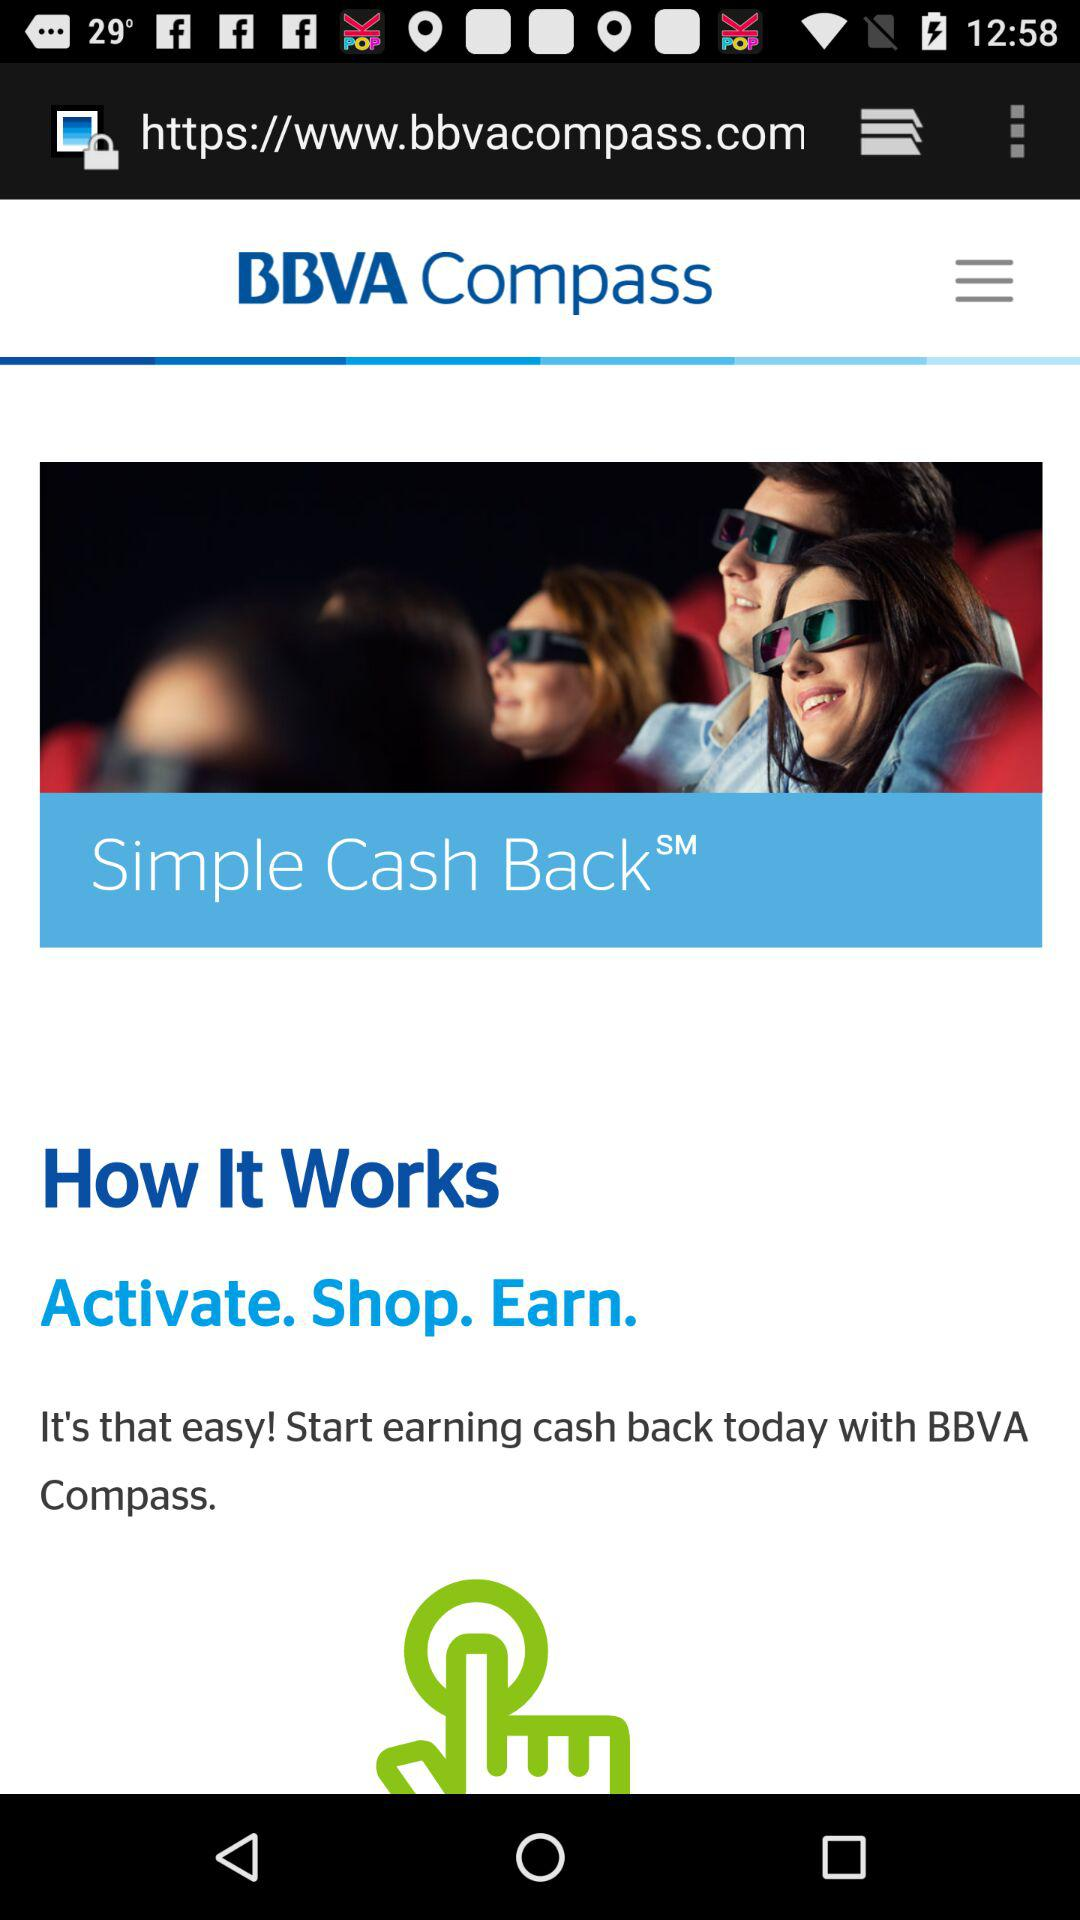What is the name of the application? The name of the application is "BBVA Compass". 